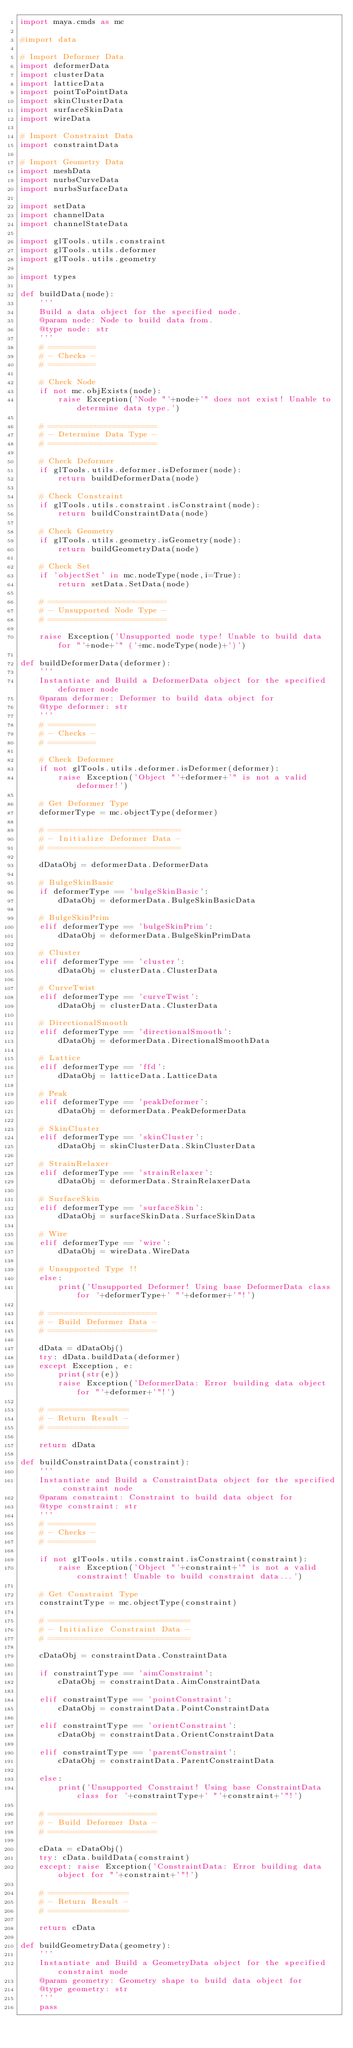<code> <loc_0><loc_0><loc_500><loc_500><_Python_>import maya.cmds as mc

#import data

# Import Deformer Data
import deformerData
import clusterData
import latticeData
import pointToPointData
import skinClusterData
import surfaceSkinData
import wireData

# Import Constraint Data
import constraintData

# Import Geometry Data
import meshData
import nurbsCurveData
import nurbsSurfaceData

import setData
import channelData
import channelStateData

import glTools.utils.constraint
import glTools.utils.deformer
import glTools.utils.geometry

import types

def buildData(node):
	'''
	Build a data object for the specified node.
	@param node: Node to build data from.
	@type node: str
	'''
	# ==========
	# - Checks -
	# ==========
	
	# Check Node
	if not mc.objExists(node):
		raise Exception('Node "'+node+'" does not exist! Unable to determine data type.')
	
	# =======================
	# - Determine Data Type -
	# =======================
	
	# Check Deformer
	if glTools.utils.deformer.isDeformer(node):
		return buildDeformerData(node)
	
	# Check Constraint
	if glTools.utils.constraint.isConstraint(node):
		return buildConstraintData(node)
	
	# Check Geometry
	if glTools.utils.geometry.isGeometry(node):
		return buildGeometryData(node)
	
	# Check Set
	if 'objectSet' in mc.nodeType(node,i=True):
		return setData.SetData(node)
	
	# =========================
	# - Unsupported Node Type -
	# =========================
	
	raise Exception('Unsupported node type! Unable to build data for "'+node+'" ('+mc.nodeType(node)+')')

def buildDeformerData(deformer):
	'''
	Instantiate and Build a DeformerData object for the specified deformer node
	@param deformer: Deformer to build data object for
	@type deformer: str
	'''
	# ==========
	# - Checks -
	# ==========
	
	# Check Deformer
	if not glTools.utils.deformer.isDeformer(deformer):
		raise Exception('Object "'+deformer+'" is not a valid deformer!')
	
	# Get Deformer Type
	deformerType = mc.objectType(deformer)
	
	# ============================
	# - Initialize Deformer Data -
	# ============================
	
	dDataObj = deformerData.DeformerData
	
	# BulgeSkinBasic
	if deformerType == 'bulgeSkinBasic':
		dDataObj = deformerData.BulgeSkinBasicData
	
	# BulgeSkinPrim
	elif deformerType == 'bulgeSkinPrim':
		dDataObj = deformerData.BulgeSkinPrimData
	
	# Cluster
	elif deformerType == 'cluster':
		dDataObj = clusterData.ClusterData
	
	# CurveTwist
	elif deformerType == 'curveTwist':
		dDataObj = clusterData.ClusterData
	
	# DirectionalSmooth
	elif deformerType == 'directionalSmooth':
		dDataObj = deformerData.DirectionalSmoothData
	
	# Lattice
	elif deformerType == 'ffd':
		dDataObj = latticeData.LatticeData
	
	# Peak
	elif deformerType == 'peakDeformer':
		dDataObj = deformerData.PeakDeformerData
	
	# SkinCluster
	elif deformerType == 'skinCluster':
		dDataObj = skinClusterData.SkinClusterData
	
	# StrainRelaxer
	elif deformerType == 'strainRelaxer':
		dDataObj = deformerData.StrainRelaxerData
		
	# SurfaceSkin
	elif deformerType == 'surfaceSkin':
		dDataObj = surfaceSkinData.SurfaceSkinData
	
	# Wire
	elif deformerType == 'wire':
		dDataObj = wireData.WireData
	
	# Unsupported Type !!
	else:
		print('Unsupported Deformer! Using base DeformerData class for '+deformerType+' "'+deformer+'"!')
	
	# =======================
	# - Build Deformer Data -
	# =======================
	
	dData = dDataObj()
	try: dData.buildData(deformer)
	except Exception, e:
		print(str(e))
		raise Exception('DeformerData: Error building data object for "'+deformer+'"!')
	
	# =================
	# - Return Result -
	# =================
	
	return dData

def buildConstraintData(constraint):
	'''
	Instantiate and Build a ConstraintData object for the specified constraint node
	@param constraint: Constraint to build data object for
	@type constraint: str
	'''
	# ==========
	# - Checks -
	# ==========
	
	if not glTools.utils.constraint.isConstraint(constraint):
		raise Exception('Object "'+constraint+'" is not a valid constraint! Unable to build constraint data...')
	
	# Get Constraint Type
	constraintType = mc.objectType(constraint)
	
	# ==============================
	# - Initialize Constraint Data -
	# ==============================
	
	cDataObj = constraintData.ConstraintData
	
	if constraintType == 'aimConstraint':
		cDataObj = constraintData.AimConstraintData
	
	elif constraintType == 'pointConstraint':
		cDataObj = constraintData.PointConstraintData
	
	elif constraintType == 'orientConstraint':
		cDataObj = constraintData.OrientConstraintData
	
	elif constraintType == 'parentConstraint':
		cDataObj = constraintData.ParentConstraintData
	
	else:
		print('Unsupported Constraint! Using base ConstraintData class for '+constraintType+' "'+constraint+'"!')
	
	# =======================
	# - Build Deformer Data -
	# =======================
	
	cData = cDataObj()
	try: cData.buildData(constraint)
	except: raise Exception('ConstraintData: Error building data object for "'+constraint+'"!')
	
	# =================
	# - Return Result -
	# =================
	
	return cData

def buildGeometryData(geometry):
	'''
	Instantiate and Build a GeometryData object for the specified constraint node
	@param geometry: Geometry shape to build data object for
	@type geometry: str
	'''
	pass
</code> 